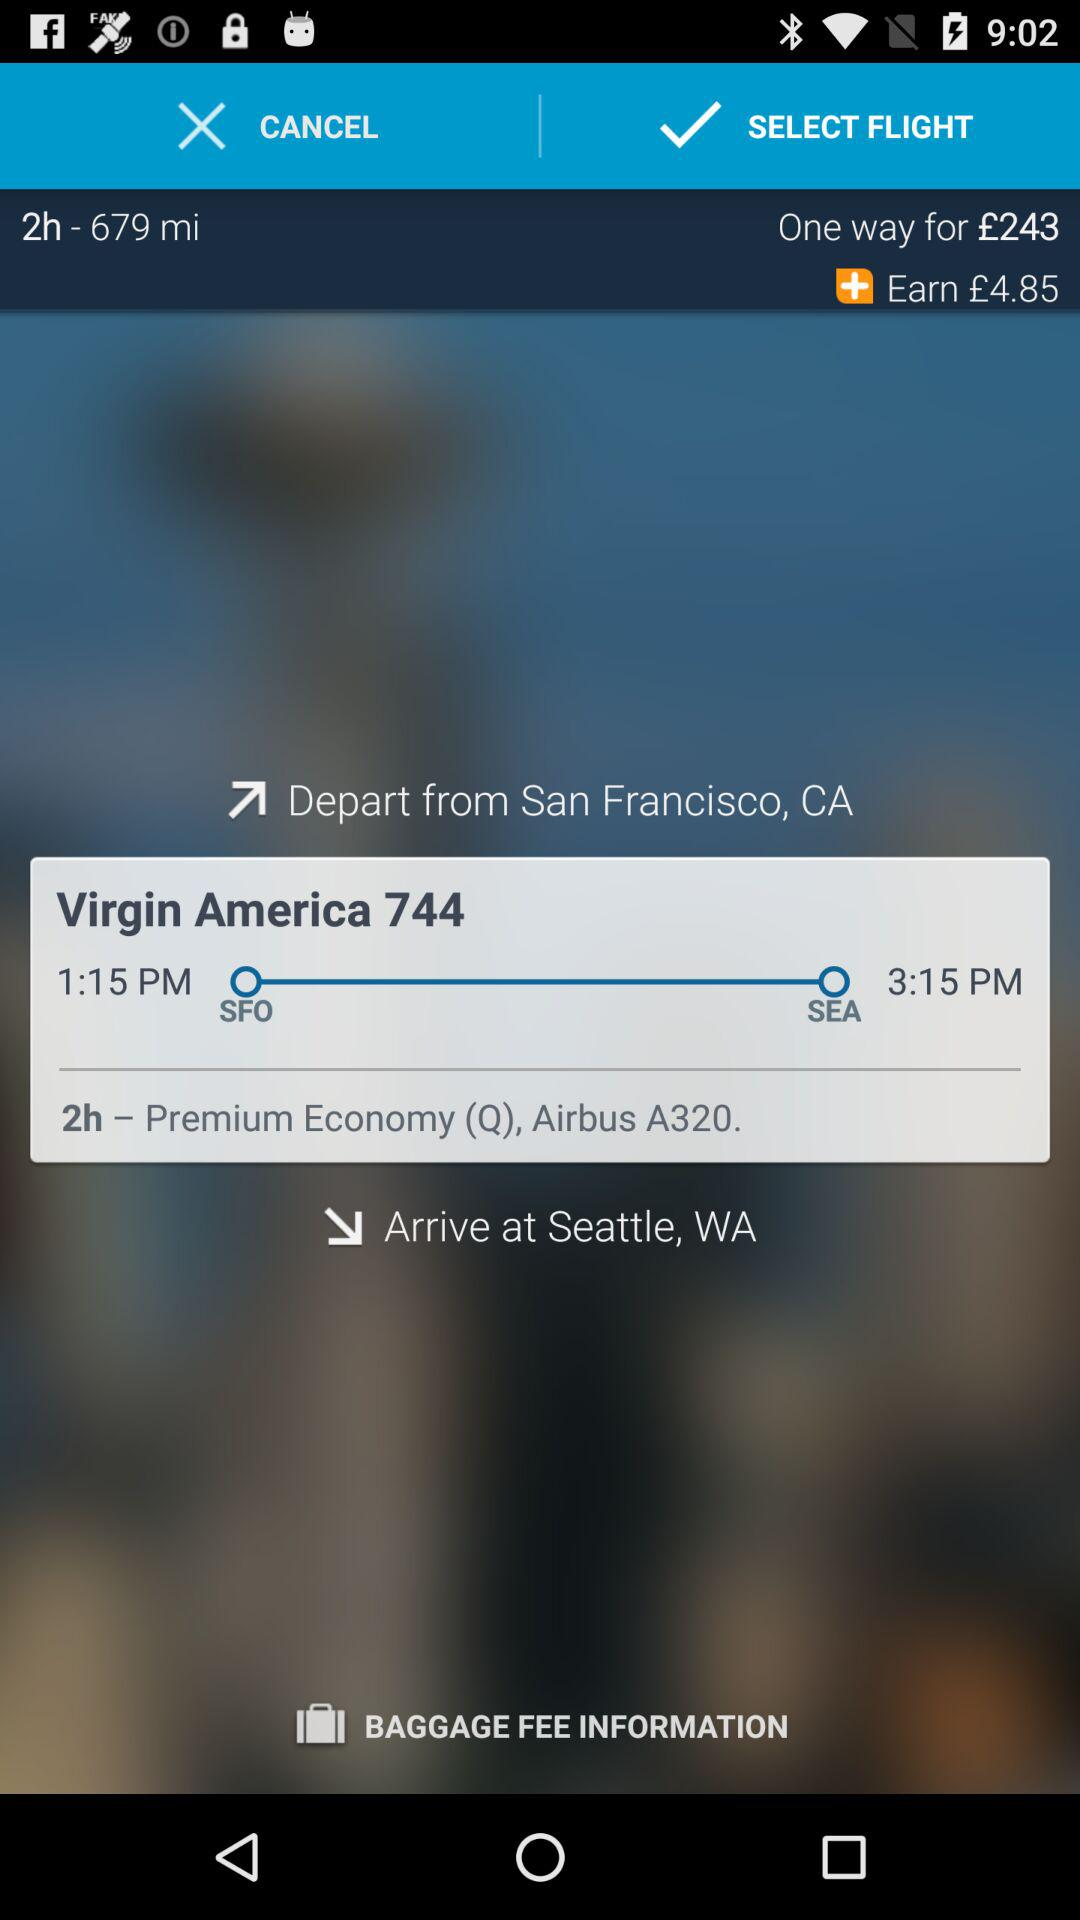Can you tell me the cost of this flight and any included benefits? The cost of the one-way ticket for this flight is £243, which includes earning a reward of £4.85. Additional benefits can include Premium Economy seating comfortable for a 2-hour journey, as well as the standard features of an Airbus A320 aircraft. However, for baggage fee information or other specific perks, you would need to check with the airline or the booking platform. 